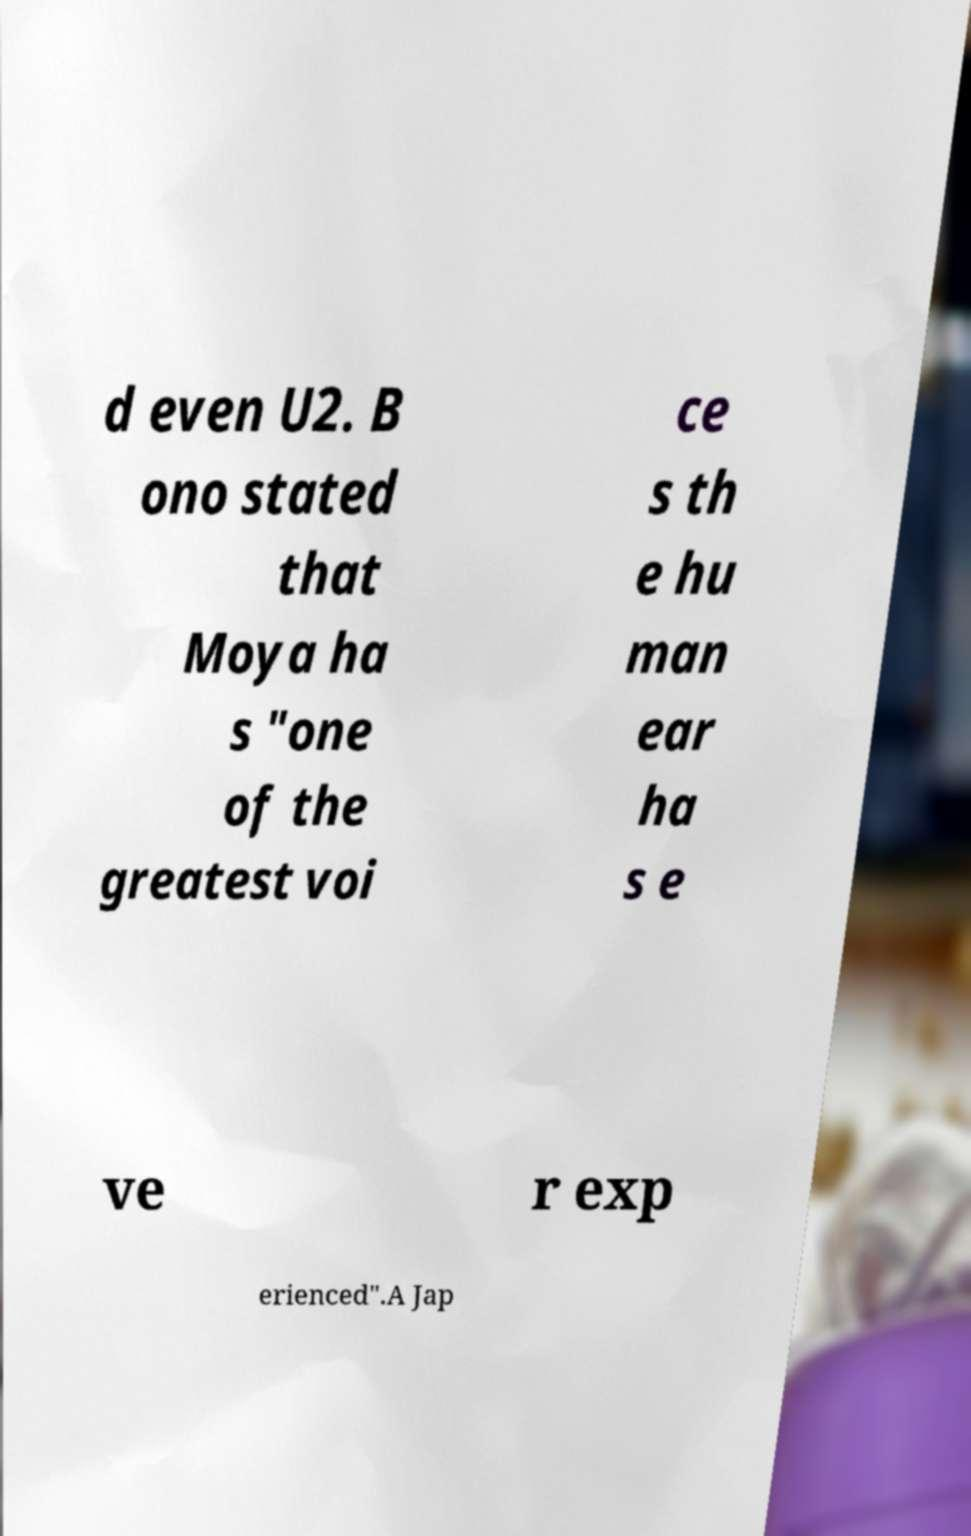There's text embedded in this image that I need extracted. Can you transcribe it verbatim? d even U2. B ono stated that Moya ha s "one of the greatest voi ce s th e hu man ear ha s e ve r exp erienced".A Jap 